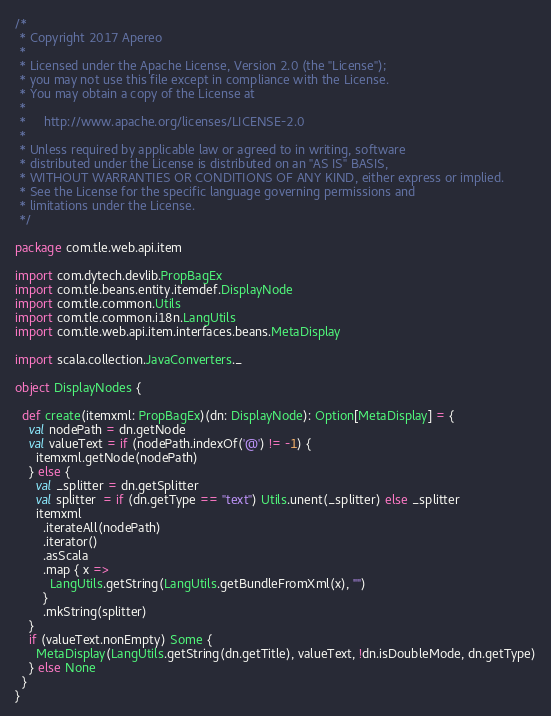Convert code to text. <code><loc_0><loc_0><loc_500><loc_500><_Scala_>/*
 * Copyright 2017 Apereo
 *
 * Licensed under the Apache License, Version 2.0 (the "License");
 * you may not use this file except in compliance with the License.
 * You may obtain a copy of the License at
 *
 *     http://www.apache.org/licenses/LICENSE-2.0
 *
 * Unless required by applicable law or agreed to in writing, software
 * distributed under the License is distributed on an "AS IS" BASIS,
 * WITHOUT WARRANTIES OR CONDITIONS OF ANY KIND, either express or implied.
 * See the License for the specific language governing permissions and
 * limitations under the License.
 */

package com.tle.web.api.item

import com.dytech.devlib.PropBagEx
import com.tle.beans.entity.itemdef.DisplayNode
import com.tle.common.Utils
import com.tle.common.i18n.LangUtils
import com.tle.web.api.item.interfaces.beans.MetaDisplay

import scala.collection.JavaConverters._

object DisplayNodes {

  def create(itemxml: PropBagEx)(dn: DisplayNode): Option[MetaDisplay] = {
    val nodePath = dn.getNode
    val valueText = if (nodePath.indexOf('@') != -1) {
      itemxml.getNode(nodePath)
    } else {
      val _splitter = dn.getSplitter
      val splitter  = if (dn.getType == "text") Utils.unent(_splitter) else _splitter
      itemxml
        .iterateAll(nodePath)
        .iterator()
        .asScala
        .map { x =>
          LangUtils.getString(LangUtils.getBundleFromXml(x), "")
        }
        .mkString(splitter)
    }
    if (valueText.nonEmpty) Some {
      MetaDisplay(LangUtils.getString(dn.getTitle), valueText, !dn.isDoubleMode, dn.getType)
    } else None
  }
}
</code> 